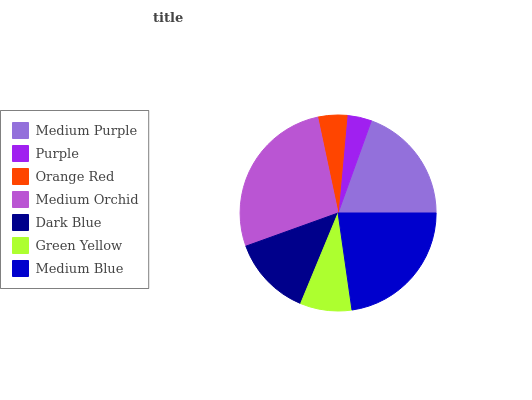Is Purple the minimum?
Answer yes or no. Yes. Is Medium Orchid the maximum?
Answer yes or no. Yes. Is Orange Red the minimum?
Answer yes or no. No. Is Orange Red the maximum?
Answer yes or no. No. Is Orange Red greater than Purple?
Answer yes or no. Yes. Is Purple less than Orange Red?
Answer yes or no. Yes. Is Purple greater than Orange Red?
Answer yes or no. No. Is Orange Red less than Purple?
Answer yes or no. No. Is Dark Blue the high median?
Answer yes or no. Yes. Is Dark Blue the low median?
Answer yes or no. Yes. Is Purple the high median?
Answer yes or no. No. Is Medium Orchid the low median?
Answer yes or no. No. 